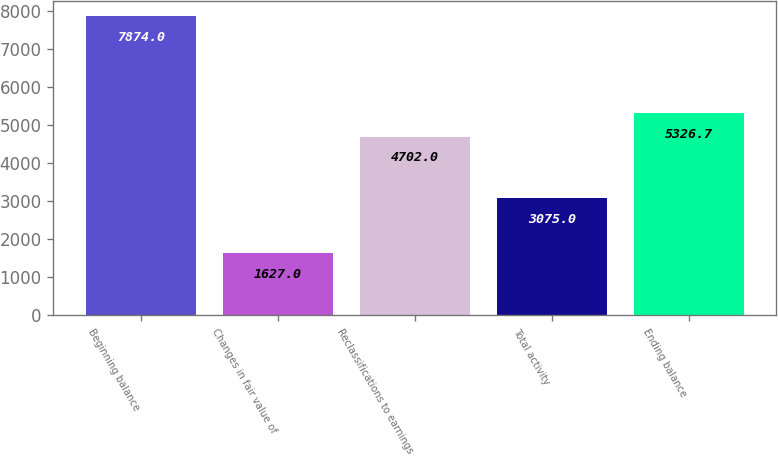Convert chart to OTSL. <chart><loc_0><loc_0><loc_500><loc_500><bar_chart><fcel>Beginning balance<fcel>Changes in fair value of<fcel>Reclassifications to earnings<fcel>Total activity<fcel>Ending balance<nl><fcel>7874<fcel>1627<fcel>4702<fcel>3075<fcel>5326.7<nl></chart> 